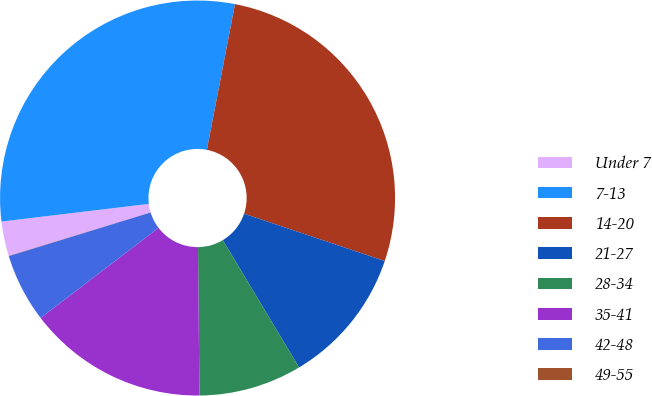<chart> <loc_0><loc_0><loc_500><loc_500><pie_chart><fcel>Under 7<fcel>7-13<fcel>14-20<fcel>21-27<fcel>28-34<fcel>35-41<fcel>42-48<fcel>49-55<nl><fcel>2.83%<fcel>29.94%<fcel>27.13%<fcel>11.24%<fcel>8.44%<fcel>14.77%<fcel>5.63%<fcel>0.02%<nl></chart> 